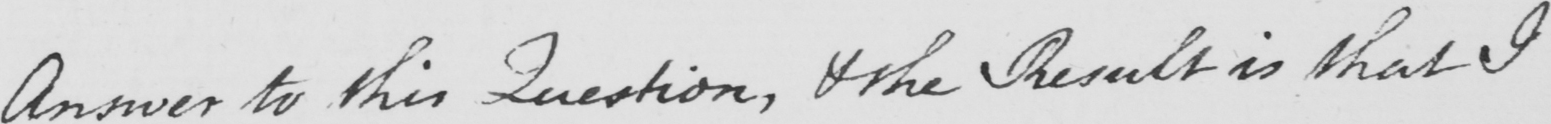Can you read and transcribe this handwriting? Answer to this Question , and the Results is that I 